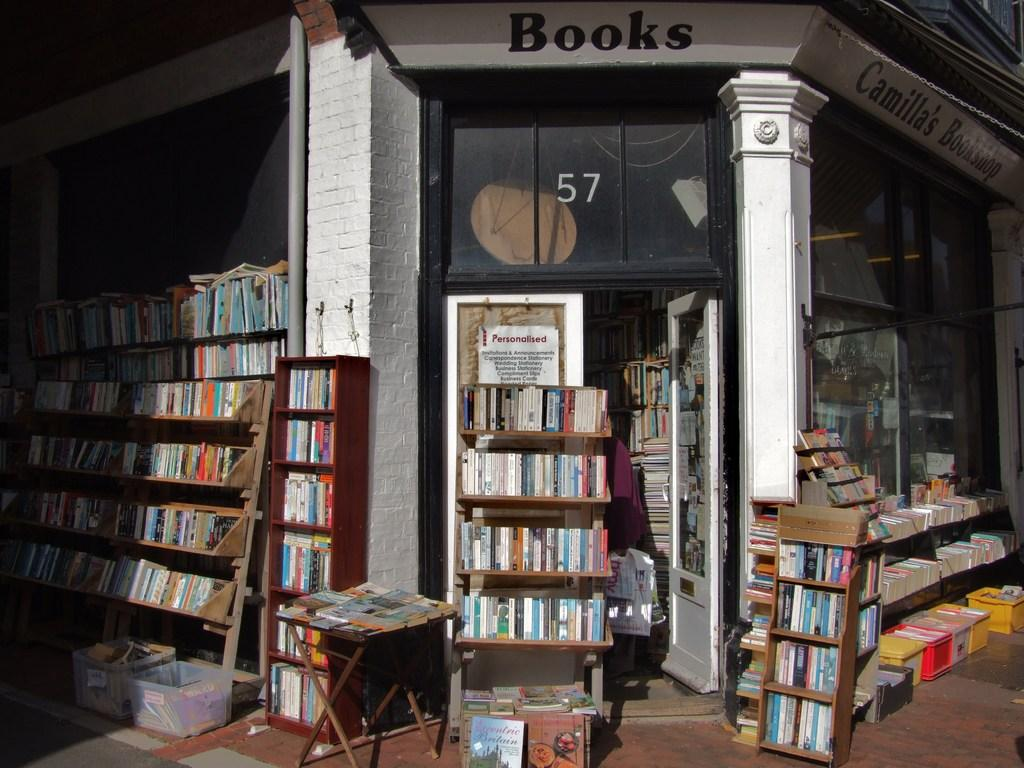<image>
Give a short and clear explanation of the subsequent image. a building with the number 57 on it 